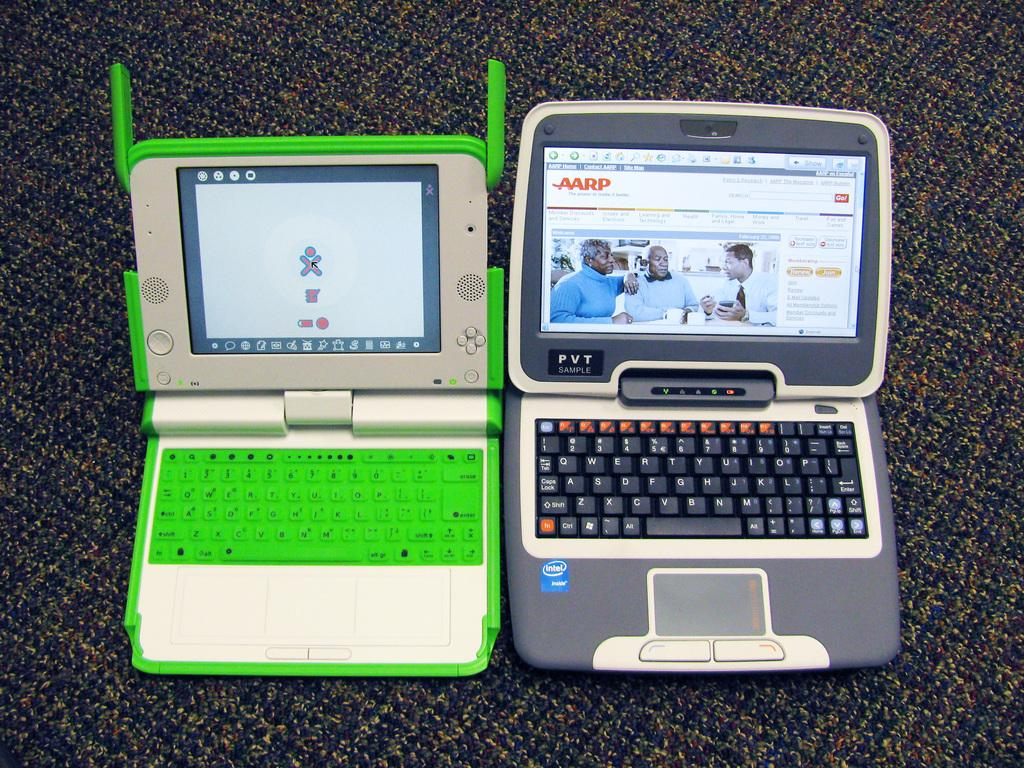<image>
Provide a brief description of the given image. A green laptop sits next to a gray laptop which is open to AARP's homepage. 